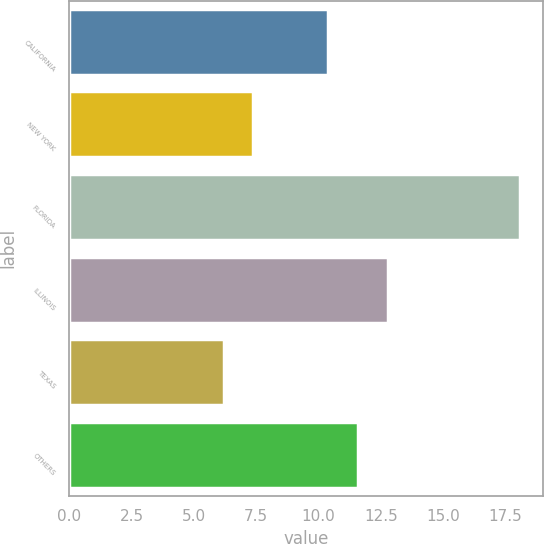<chart> <loc_0><loc_0><loc_500><loc_500><bar_chart><fcel>CALIFORNIA<fcel>NEW YORK<fcel>FLORIDA<fcel>ILLINOIS<fcel>TEXAS<fcel>OTHERS<nl><fcel>10.4<fcel>7.39<fcel>18.1<fcel>12.78<fcel>6.2<fcel>11.59<nl></chart> 